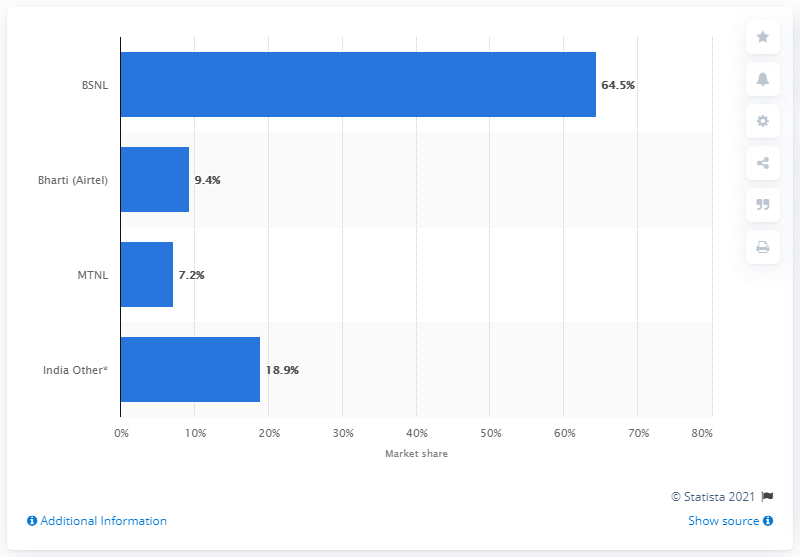Specify some key components in this picture. In the fourth quarter of 2013, BSNL held a market share of 64.5%. 